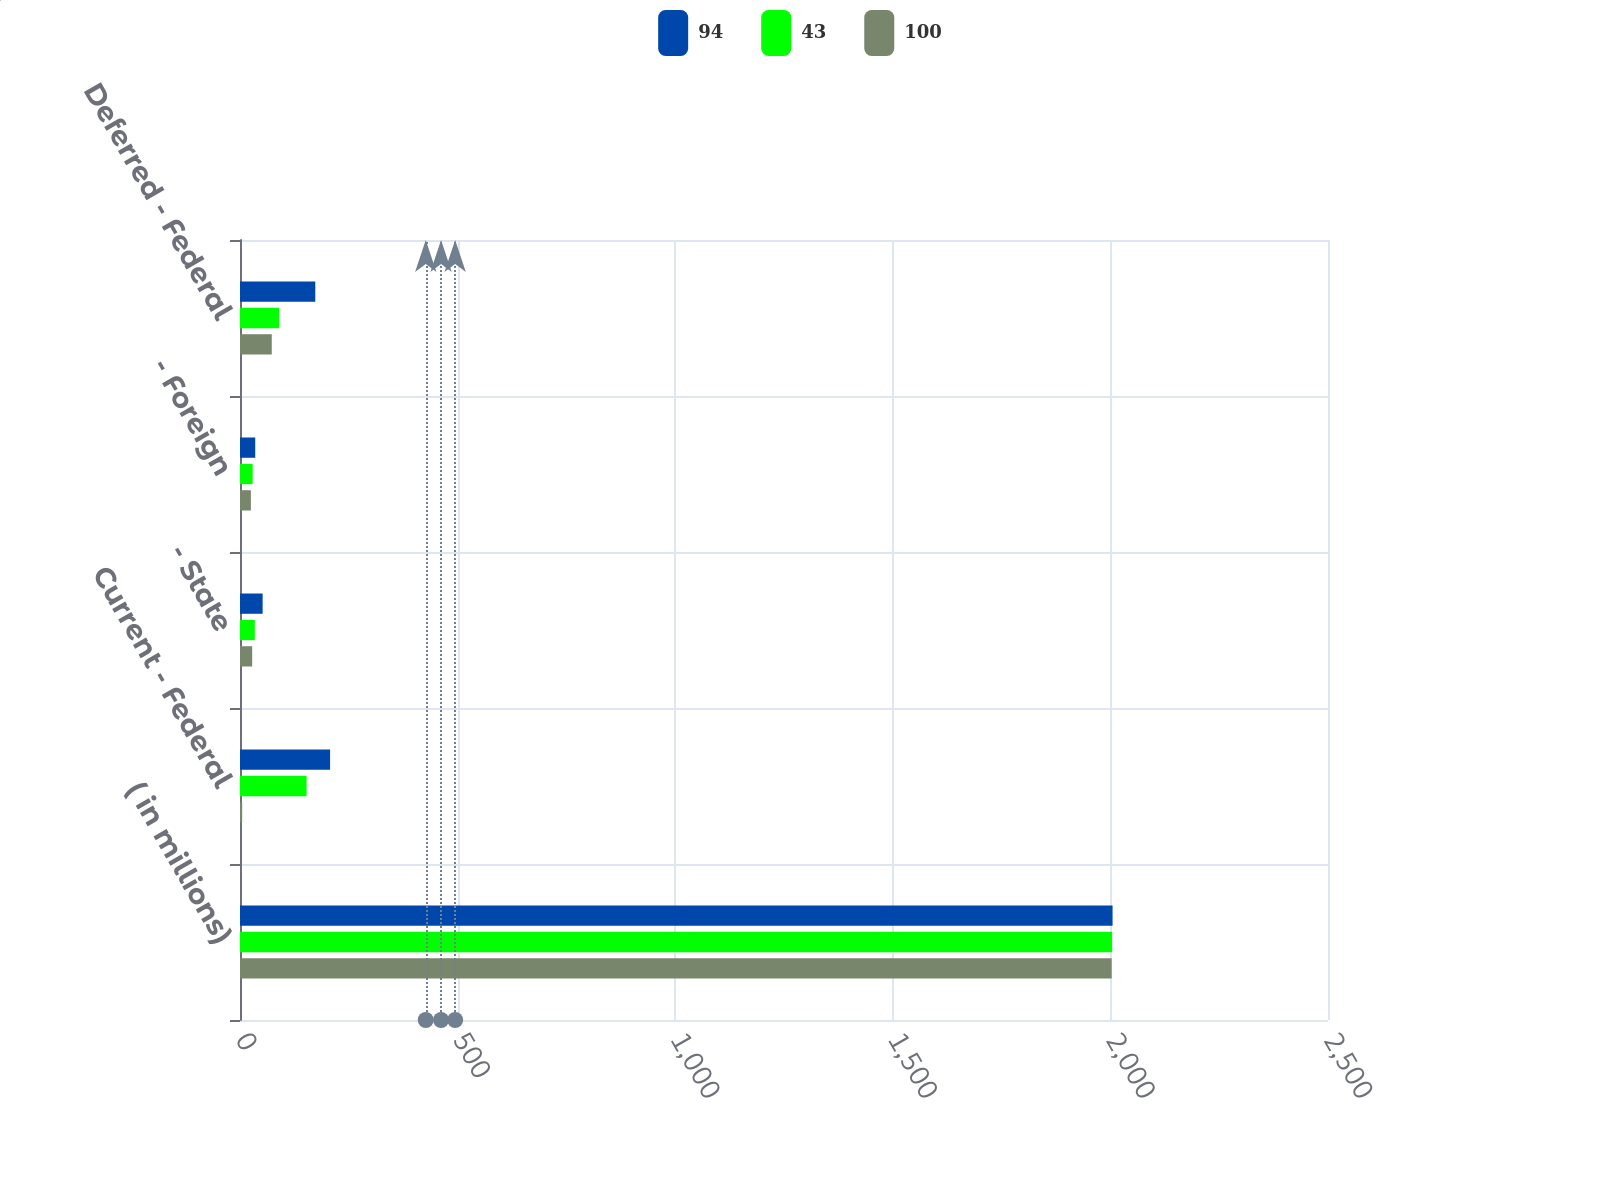Convert chart. <chart><loc_0><loc_0><loc_500><loc_500><stacked_bar_chart><ecel><fcel>( in millions)<fcel>Current - Federal<fcel>- State<fcel>- Foreign<fcel>Deferred - Federal<nl><fcel>94<fcel>2005<fcel>207<fcel>52<fcel>35<fcel>173<nl><fcel>43<fcel>2004<fcel>153<fcel>34<fcel>29<fcel>90<nl><fcel>100<fcel>2003<fcel>5<fcel>28<fcel>25<fcel>73<nl></chart> 